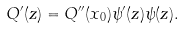Convert formula to latex. <formula><loc_0><loc_0><loc_500><loc_500>Q ^ { \prime } ( z ) = Q ^ { \prime \prime } ( x _ { 0 } ) \psi ^ { \prime } ( z ) \psi ( z ) .</formula> 